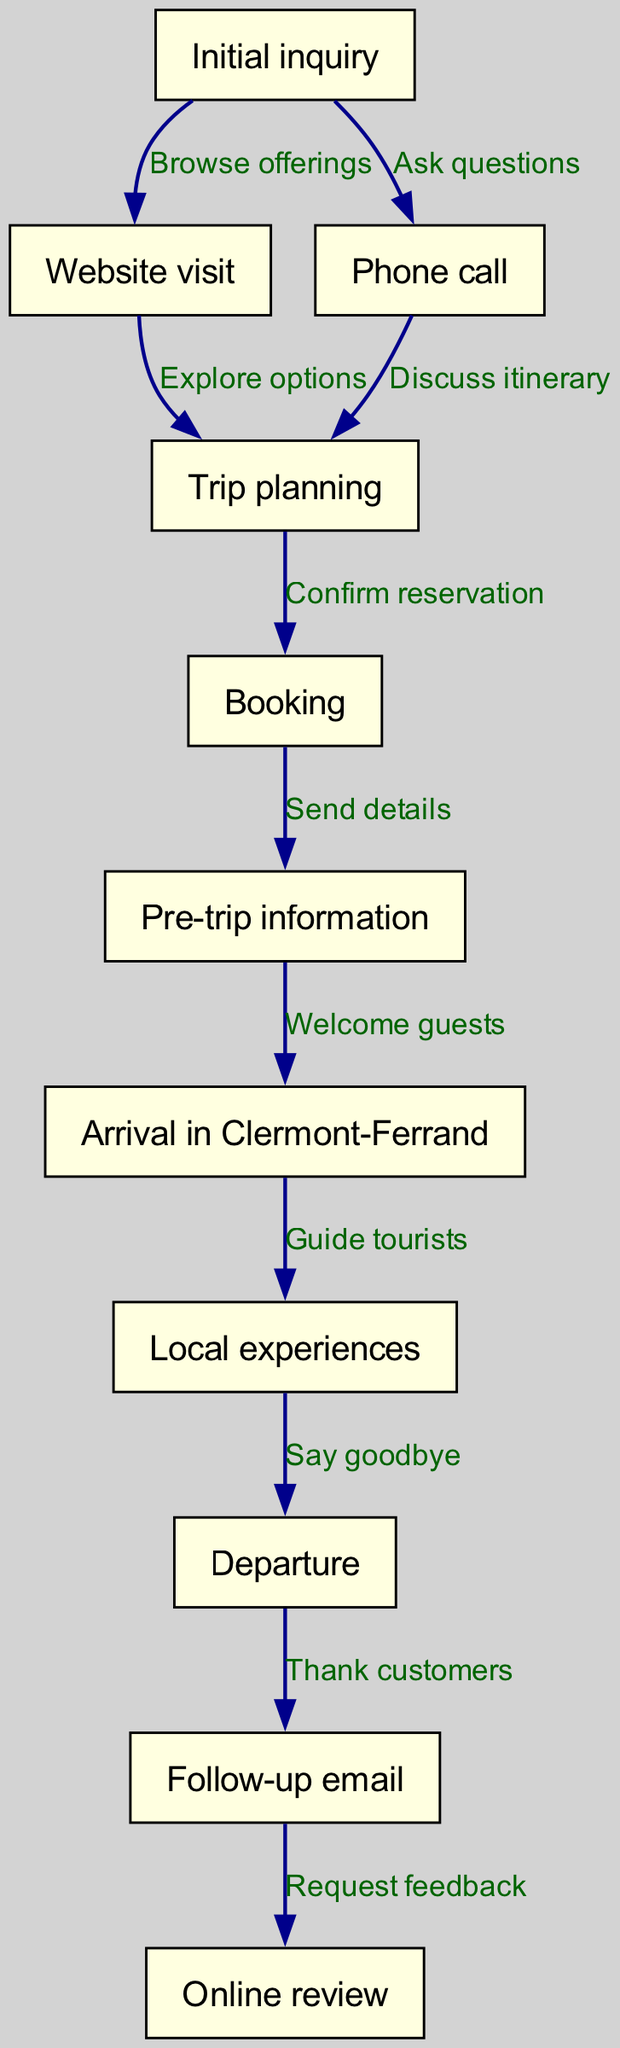What is the first step in the customer journey? The first step in the customer journey, as indicated in the diagram, is the "Initial inquiry" node. This serves as the starting point for the journey.
Answer: Initial inquiry How many nodes are in the diagram? By counting the specific elements listed in the nodes section of the diagram, we see there are a total of 11 distinct nodes representing various stages of the customer journey.
Answer: 11 What is the relationship between "Booking" and "Pre-trip information"? According to the diagram, the edge between "Booking" and "Pre-trip information" indicates that after booking, the action taken is to "Send details", showing a direct flow of information.
Answer: Send details Which node follows "Departure"? In the sequence of the customer journey depicted in the diagram, "Follow-up email" directly follows "Departure", as shown by the arrow linking the two nodes.
Answer: Follow-up email What are the last two steps in the customer journey? The last two steps in the journey, moving in order from the penultimate step, are "Departure" followed by "Follow-up email", indicating final actions after the trip concludes.
Answer: Departure, Follow-up email What action do customers take after receiving "Pre-trip information"? Based on the flow of the diagram, after receiving "Pre-trip information", customers arrive in "Clermont-Ferrand", marking the transition from preparation to the actual experience.
Answer: Arrival in Clermont-Ferrand How many edges are present in the diagram? By counting the connections between nodes, we can deduce that there are 10 distinct edges representing the transitions and actions occurring between the various stages in the customer journey.
Answer: 10 Which node represents customer feedback? The node that explicitly indicates customer feedback in the diagram is "Online review", which is reached after the "Follow-up email" prompts this action.
Answer: Online review What is the purpose of the edge labeled "Thank customers"? This edge shows the action of sending a "Thank customers" note from "Departure" to "Follow-up email", indicating a typical post-service courtesy extended to customers.
Answer: Thank customers What is the transition from "Local experiences" to "Departure"? The transition from "Local experiences" to "Departure" is labeled "Say goodbye", indicating how experiences culminate into the farewell process for the tourists.
Answer: Say goodbye 